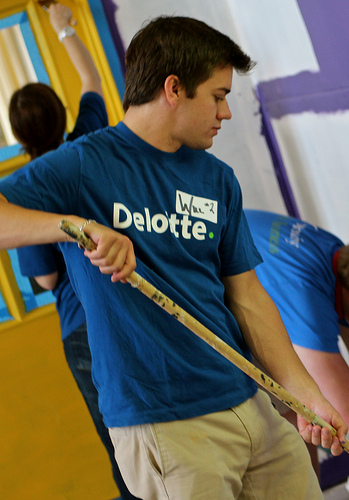<image>
Can you confirm if the wall is behind the man? Yes. From this viewpoint, the wall is positioned behind the man, with the man partially or fully occluding the wall. 